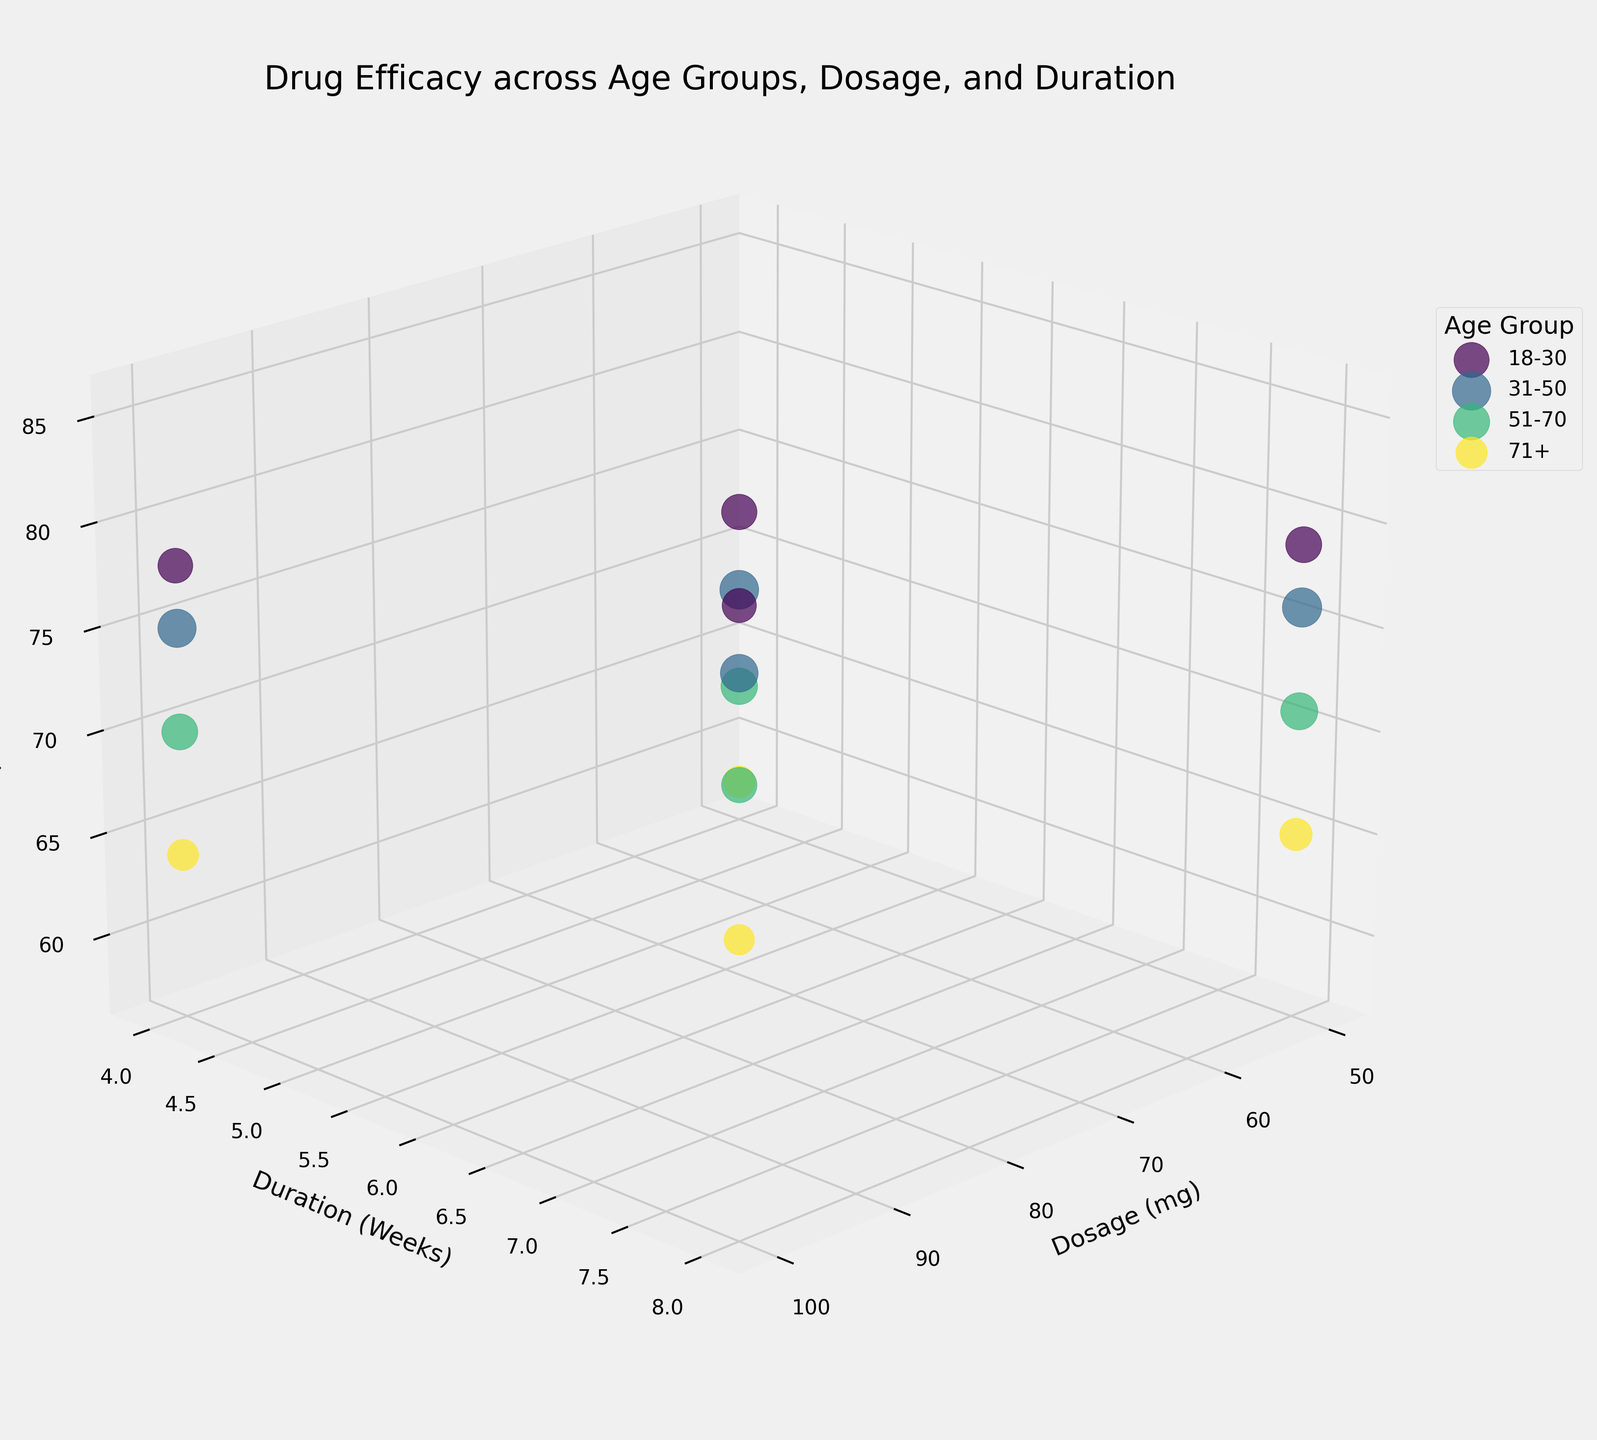What is the title of the plot? The title is generally found at the top of the figure. In this case, it reads 'Drug Efficacy across Age Groups, Dosage, and Duration'.
Answer: Drug Efficacy across Age Groups, Dosage, and Duration What are the three axes labeled with? The axes labels can be found near the respective axes: the x-axis is labeled 'Dosage (mg)', the y-axis is labeled 'Duration (Weeks)', and the z-axis is labeled 'Efficacy (%)'.
Answer: Dosage (mg), Duration (Weeks), Efficacy (%) How many different age groups are represented in the plot? By looking at the legend on the right side of the plot, we can count the number of distinct age groups mentioned.
Answer: 4 Which age group shows the highest efficacy percentage and what is it? By examining the z-axis (Efficacy %) and looking for the highest point, we see that the 18-30 age group has the highest efficacy percentage of 85%.
Answer: 18-30, 85% Which age group has the lowest efficacy percentage for the 4-week duration and 50 mg dosage? Identify the points at 4 weeks and 50 mg on the x and y-axes, then find the lowest z-axis value among those points. 71+ shows the lowest efficacy at 58%.
Answer: 71+, 58% On average, how does an increase from 4 weeks to 8 weeks of treatment duration affect the efficacy percentage for the 31-50 age group? First, find the efficacy values for 31-50 at 4 weeks (68 and 75) and then at 8 weeks (76 and 82). Calculate average for each duration: (68+75)/2=71.5 and (76+82)/2=79. Then, subtract to find the effect: 79-71.5=7.5.
Answer: Increases by 7.5% For the dosage of 100 mg, which age group shows the largest increase in efficacy percentage from 4 to 8 weeks? Find the points with 100 mg dosage on the x-axis, then compare efficacy percentages between 4 and 8 weeks for each age group. Difference: 18-30: 85-78=7, 31-50: 82-75=7, 51-70: 77-70=7, 71+: 70-64=6. 18-30, 31-50, and 51-70 all increase by 7.
Answer: 18-30, 31-50, 51-70 Which dosage and duration combination shows the maximum efficacy percentage for the 51-70 age group? Look at the points for the 51-70 age group, then find the maximum point on the z-axis (Efficacy %). The highest point is at 100 mg and 8 weeks.
Answer: 100 mg, 8 weeks Among all age groups, which has the largest bubble size and what does it indicate? The bubble size represents the sample size. The largest bubble visually is from the 31-50 age group, indicating the largest sample size of 185.
Answer: 31-50, sample size of 185 